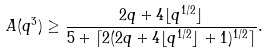Convert formula to latex. <formula><loc_0><loc_0><loc_500><loc_500>A ( q ^ { 3 } ) \geq \frac { 2 q + 4 \lfloor q ^ { 1 / 2 } \rfloor } { 5 + \lceil 2 ( 2 q + 4 \lfloor q ^ { 1 / 2 } \rfloor + 1 ) ^ { 1 / 2 } \rceil } .</formula> 